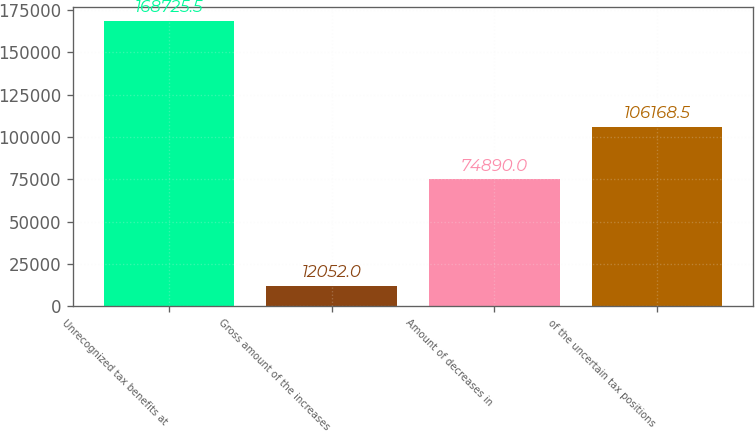Convert chart. <chart><loc_0><loc_0><loc_500><loc_500><bar_chart><fcel>Unrecognized tax benefits at<fcel>Gross amount of the increases<fcel>Amount of decreases in<fcel>of the uncertain tax positions<nl><fcel>168726<fcel>12052<fcel>74890<fcel>106168<nl></chart> 